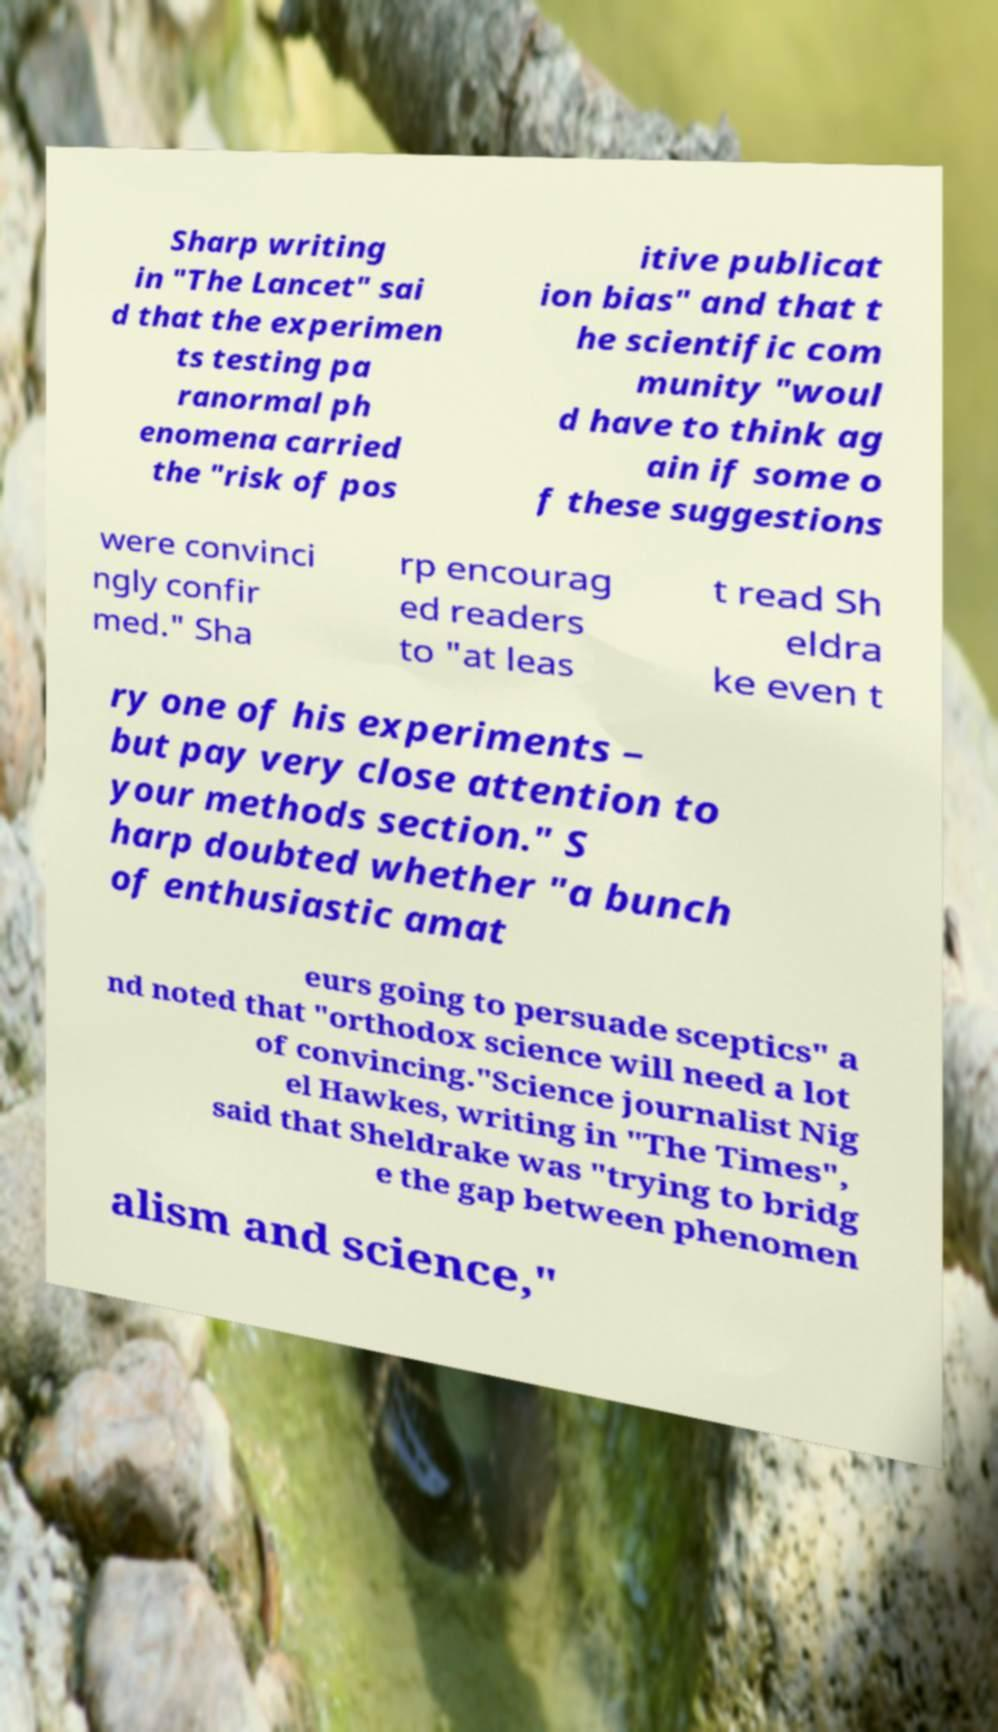Can you accurately transcribe the text from the provided image for me? Sharp writing in "The Lancet" sai d that the experimen ts testing pa ranormal ph enomena carried the "risk of pos itive publicat ion bias" and that t he scientific com munity "woul d have to think ag ain if some o f these suggestions were convinci ngly confir med." Sha rp encourag ed readers to "at leas t read Sh eldra ke even t ry one of his experiments – but pay very close attention to your methods section." S harp doubted whether "a bunch of enthusiastic amat eurs going to persuade sceptics" a nd noted that "orthodox science will need a lot of convincing."Science journalist Nig el Hawkes, writing in "The Times", said that Sheldrake was "trying to bridg e the gap between phenomen alism and science," 